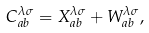<formula> <loc_0><loc_0><loc_500><loc_500>C _ { a b } ^ { \lambda \sigma } = X _ { a b } ^ { \lambda \sigma } + W _ { a b } ^ { \lambda \sigma } ,</formula> 